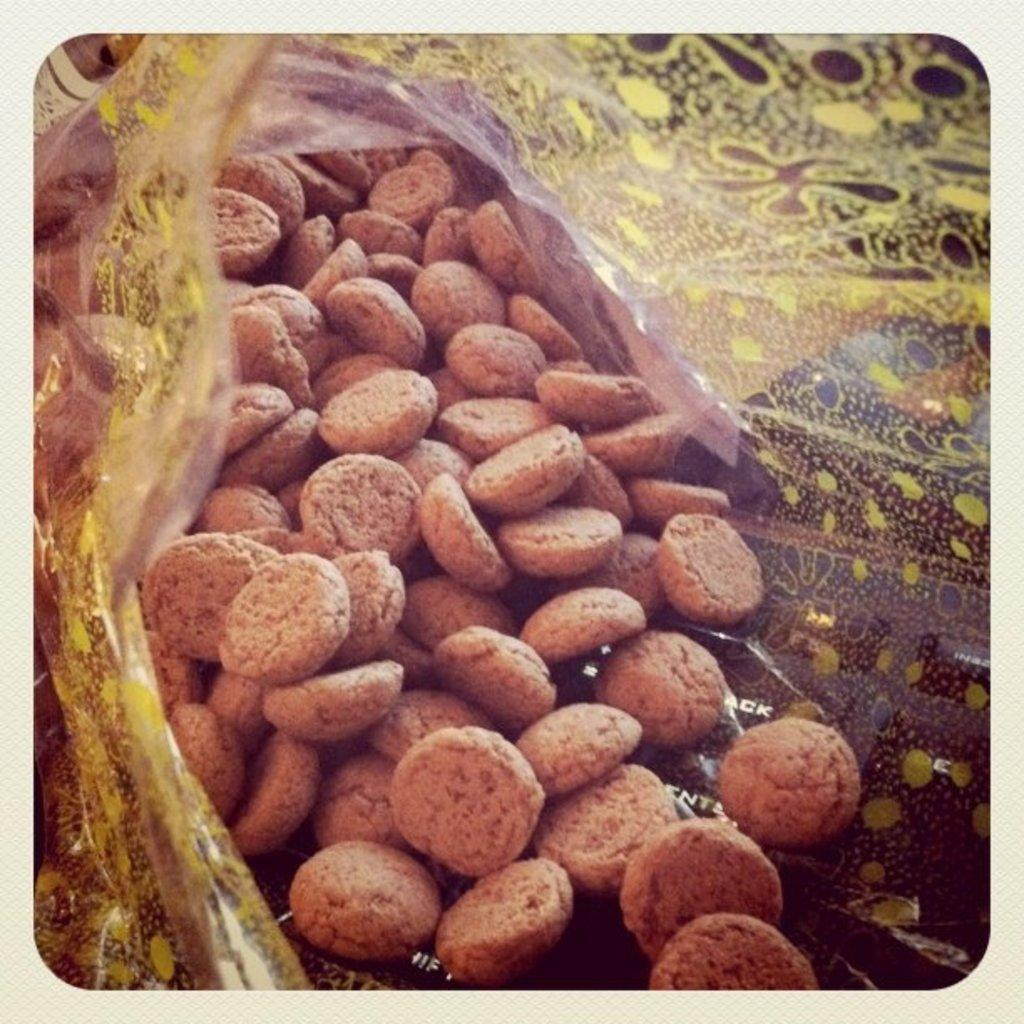What type of food can be seen in the image? The food in the image is in a circular shape. How is the circular food being presented? The food is in a cover. What type of structure can be seen in the background of the image? There is no structure visible in the image; it only shows food in a circular shape and a cover. What type of produce is being used to make the circular food? The provided facts do not mention any specific type of produce being used to make the circular food. 